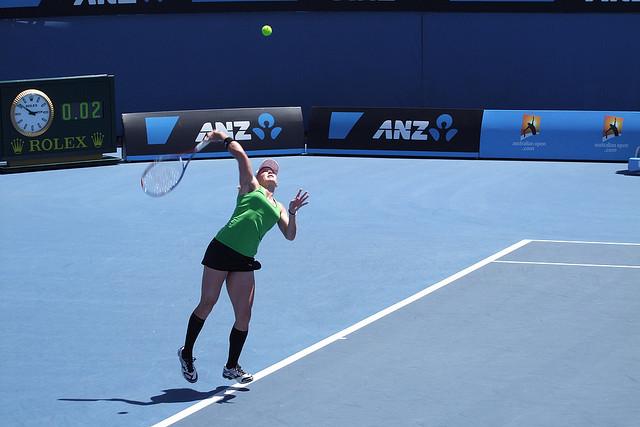Who is sponsoring the timekeeping system for the tournament?
Concise answer only. Rolex. What is the lady about to hit?
Write a very short answer. Tennis ball. What time is on the clock?
Be succinct. 2:50. 